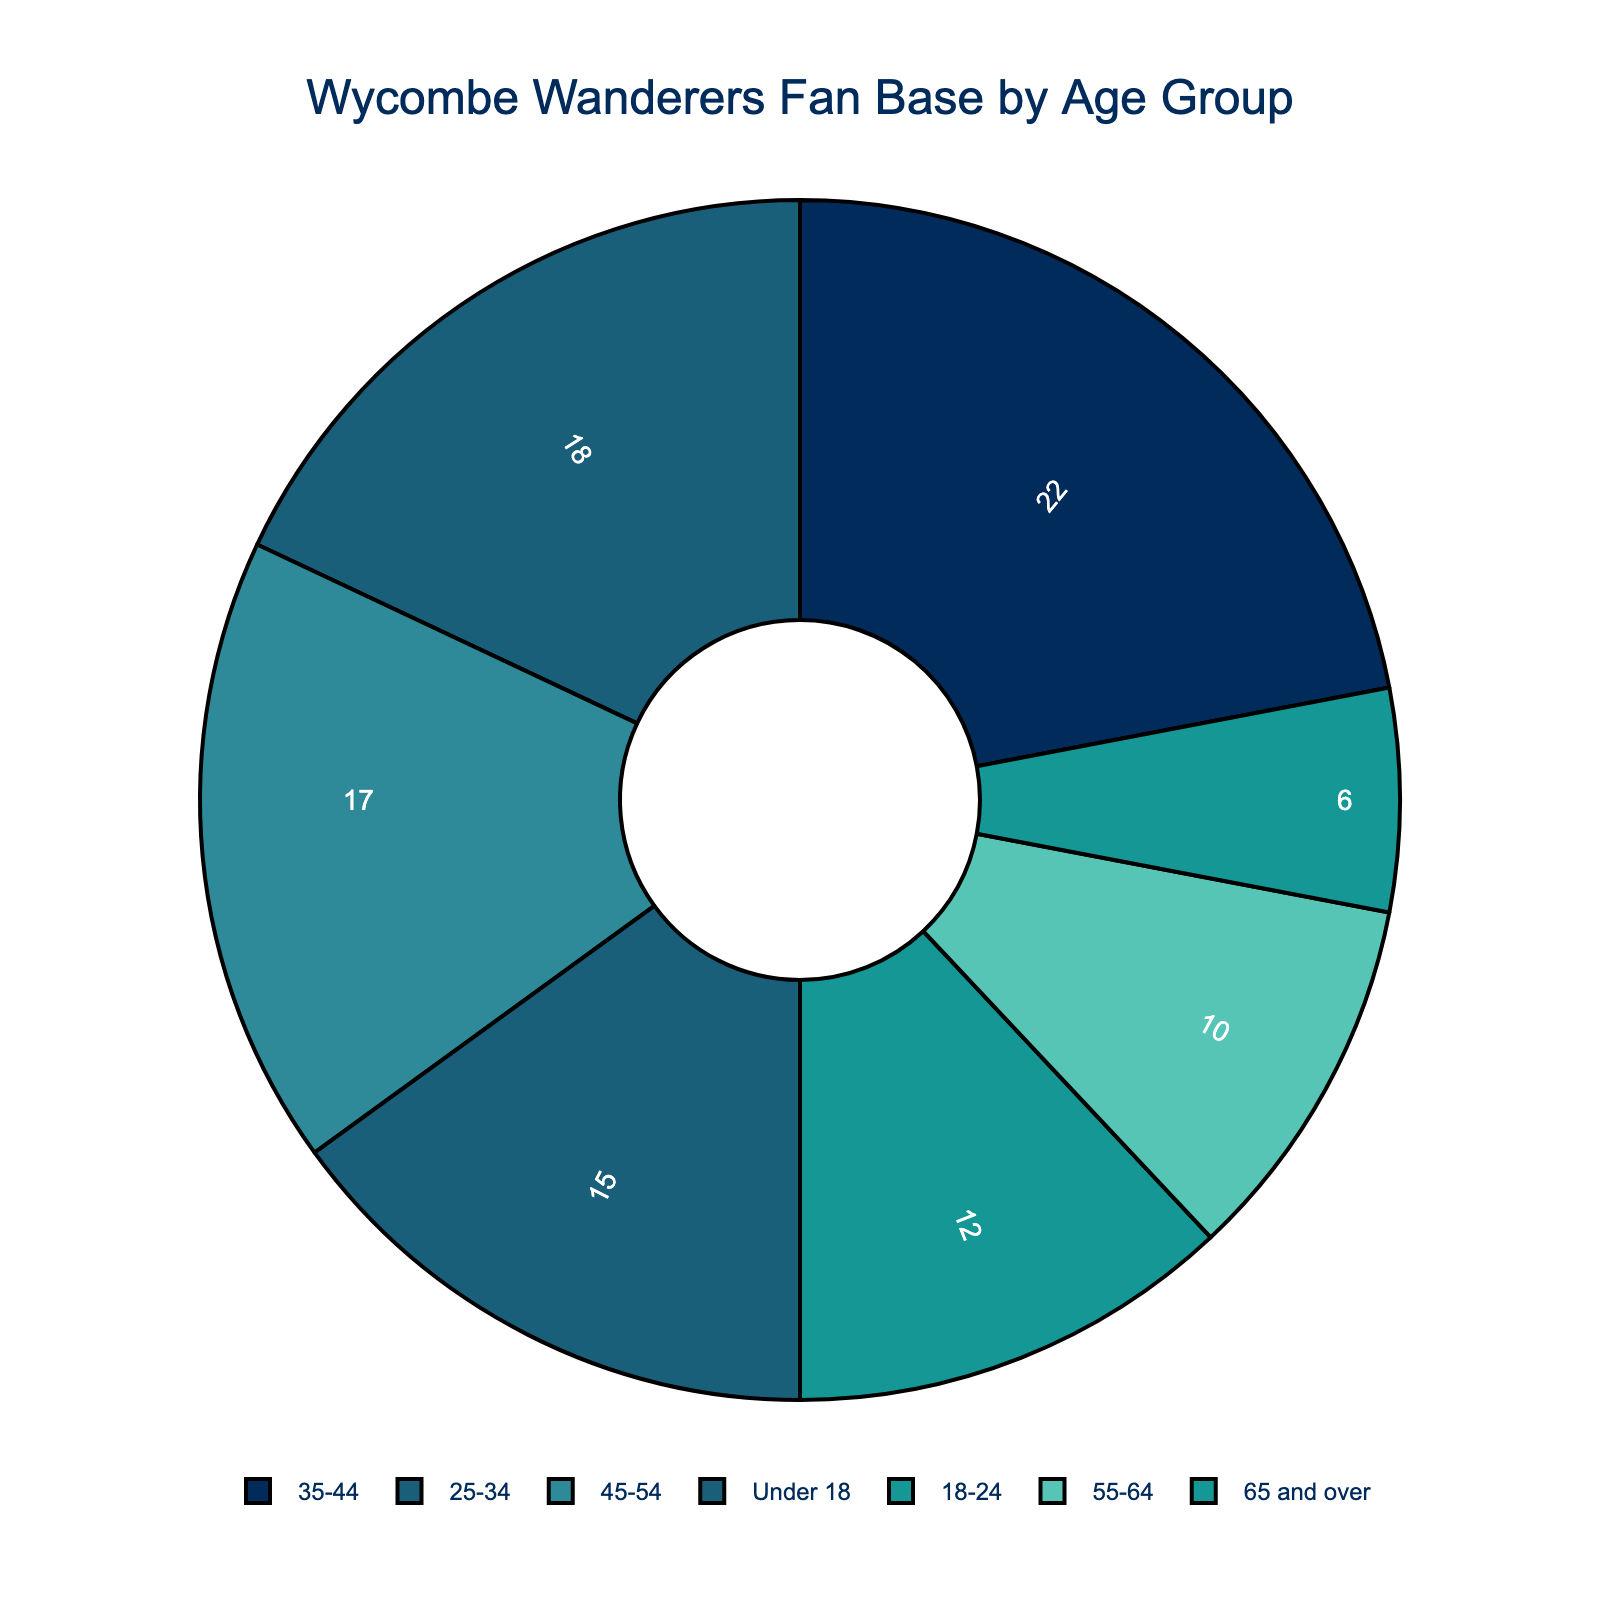What age group represents the largest percentage of Wycombe Wanderers' fan base? By observing the pie chart, we can see that the segment representing the 35-44 age group is the largest compared to other segments.
Answer: 35-44 Which two age groups combined make up less than 20% of the fan base? Referring to the percentages in the pie chart, the 55-64 age group (10%) and the 65 and over age group (6%) together total 16%, which is less than 20%.
Answer: 55-64 and 65 and over Is the percentage of fans aged 45-54 larger or smaller than those aged 25-34? From the chart, the 45-54 age group has 17%, while the 25-34 age group has 18%, making the percentage of fans aged 45-54 smaller.
Answer: Smaller What is the combined percentage of fans under 18 and 18-24? The pie chart shows that fans under 18 make up 15% and those aged 18-24 make up 12%, resulting in a total of 15% + 12% = 27%.
Answer: 27% What is the percentage difference between the largest and smallest age groups in the fan base? The 35-44 age group is the largest at 22%, and the 65 and over age group is the smallest at 6%. The difference is 22% - 6% = 16%.
Answer: 16% How does the percentage of the 25-34 age group compare to the combined percentage of the 55-64 and 65 and over age groups? The 25-34 age group is 18%, while the combined percentage of the 55-64 and 65 and over age groups is 10% + 6% = 16%, making 25-34 greater than the combined percentage of 55-64 and 65 and over.
Answer: Greater What color represents the 18-24 age group in the pie chart? The color scheme indicated in the code matches the age groups. The 18-24 age group is represented by the second color, which is a shade of teal ('#159895').
Answer: Teal Is the visual representation (height of the segment) for the 55-64 age group longer or shorter than the 18-24 age group? Comparing the segments visually, the 55-64 age group, which is 10%, is shorter than the 18-24 age group, which is 12%.
Answer: Shorter Are there more fans aged 35-44 than those aged under 18 and 18-24 combined? The 35-44 age group accounts for 22%, while the combined under 18 and 18-24 groups total 27%. Therefore, there are fewer fans aged 35-44.
Answer: No What age group has a percentage closest to the median percentage value of the data? To find the median, arrange the percentages in order: 6%, 10%, 12%, 15%, 17%, 18%, 22%. The median value is 17%, which corresponds to the 45-54 age group.
Answer: 45-54 